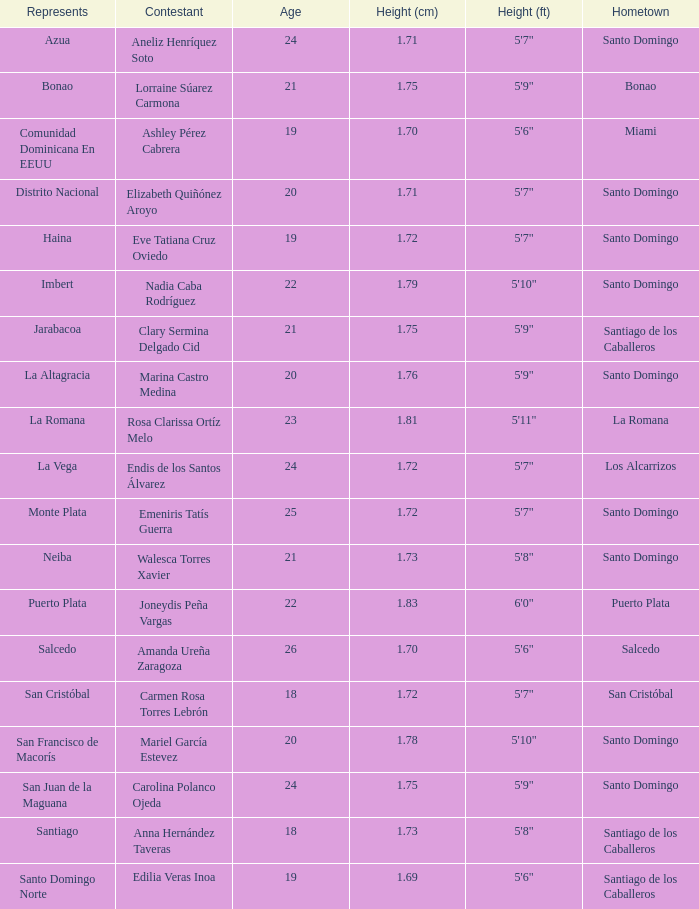Name the total number of represents for clary sermina delgado cid 1.0. 